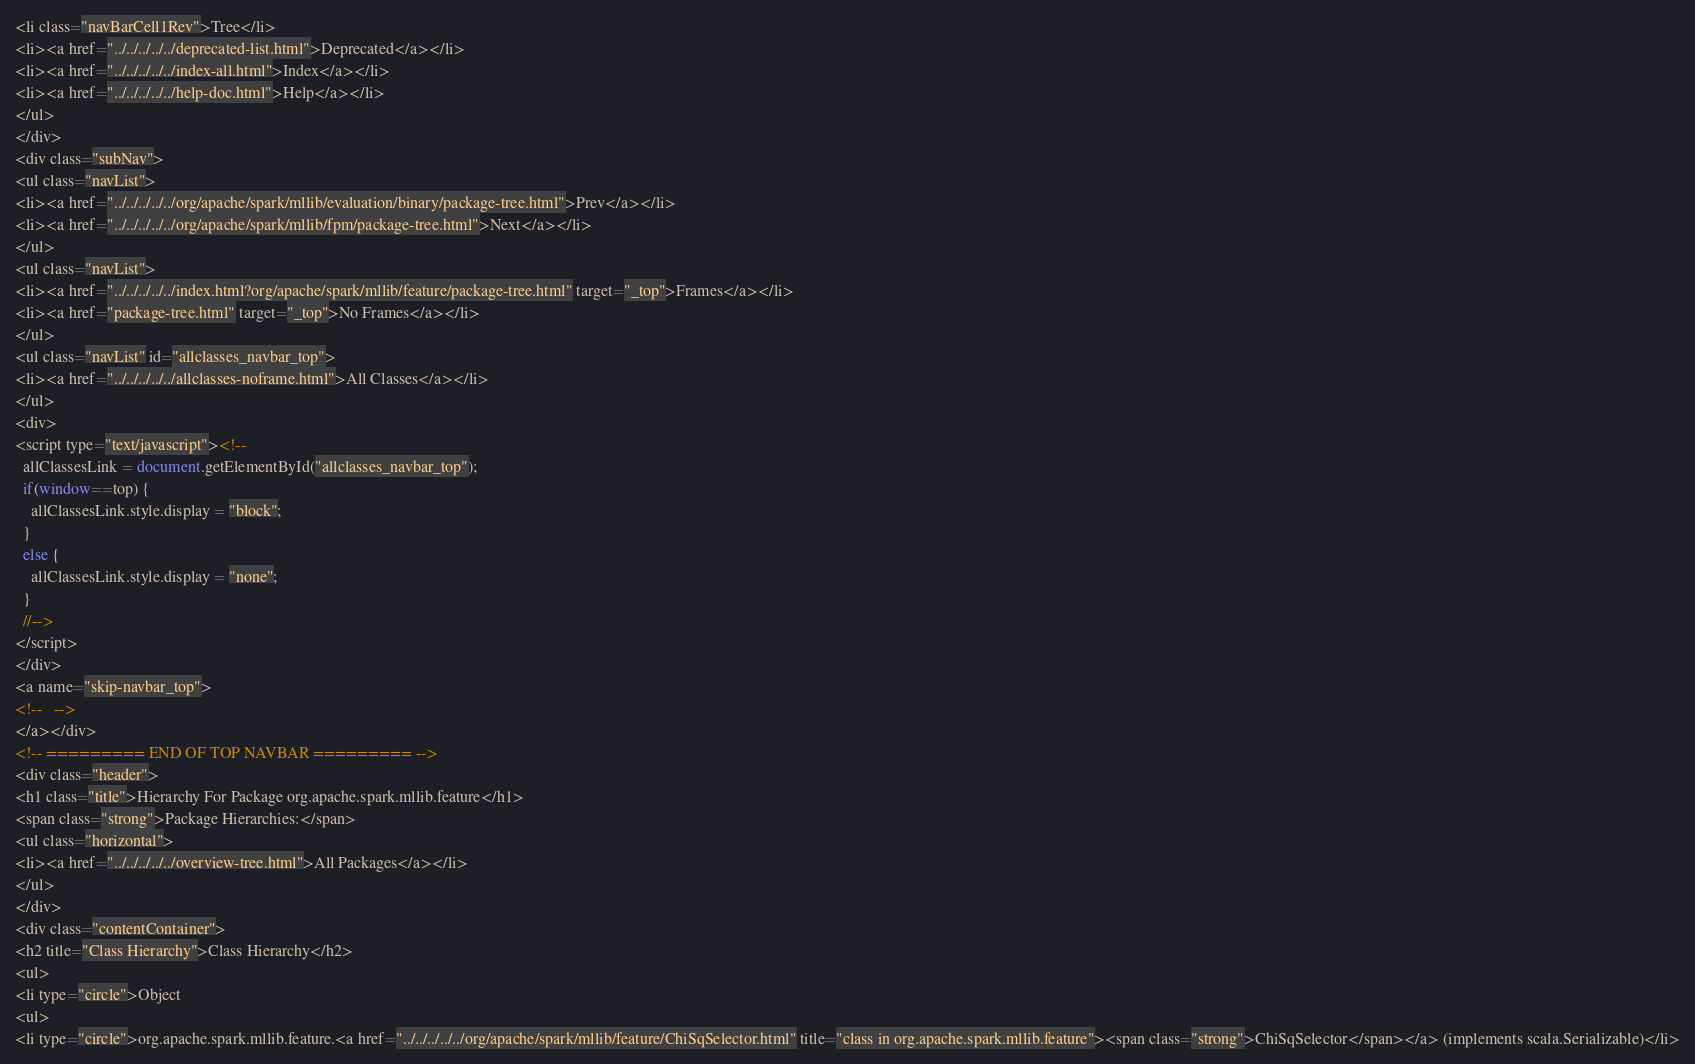<code> <loc_0><loc_0><loc_500><loc_500><_HTML_><li class="navBarCell1Rev">Tree</li>
<li><a href="../../../../../deprecated-list.html">Deprecated</a></li>
<li><a href="../../../../../index-all.html">Index</a></li>
<li><a href="../../../../../help-doc.html">Help</a></li>
</ul>
</div>
<div class="subNav">
<ul class="navList">
<li><a href="../../../../../org/apache/spark/mllib/evaluation/binary/package-tree.html">Prev</a></li>
<li><a href="../../../../../org/apache/spark/mllib/fpm/package-tree.html">Next</a></li>
</ul>
<ul class="navList">
<li><a href="../../../../../index.html?org/apache/spark/mllib/feature/package-tree.html" target="_top">Frames</a></li>
<li><a href="package-tree.html" target="_top">No Frames</a></li>
</ul>
<ul class="navList" id="allclasses_navbar_top">
<li><a href="../../../../../allclasses-noframe.html">All Classes</a></li>
</ul>
<div>
<script type="text/javascript"><!--
  allClassesLink = document.getElementById("allclasses_navbar_top");
  if(window==top) {
    allClassesLink.style.display = "block";
  }
  else {
    allClassesLink.style.display = "none";
  }
  //-->
</script>
</div>
<a name="skip-navbar_top">
<!--   -->
</a></div>
<!-- ========= END OF TOP NAVBAR ========= -->
<div class="header">
<h1 class="title">Hierarchy For Package org.apache.spark.mllib.feature</h1>
<span class="strong">Package Hierarchies:</span>
<ul class="horizontal">
<li><a href="../../../../../overview-tree.html">All Packages</a></li>
</ul>
</div>
<div class="contentContainer">
<h2 title="Class Hierarchy">Class Hierarchy</h2>
<ul>
<li type="circle">Object
<ul>
<li type="circle">org.apache.spark.mllib.feature.<a href="../../../../../org/apache/spark/mllib/feature/ChiSqSelector.html" title="class in org.apache.spark.mllib.feature"><span class="strong">ChiSqSelector</span></a> (implements scala.Serializable)</li></code> 